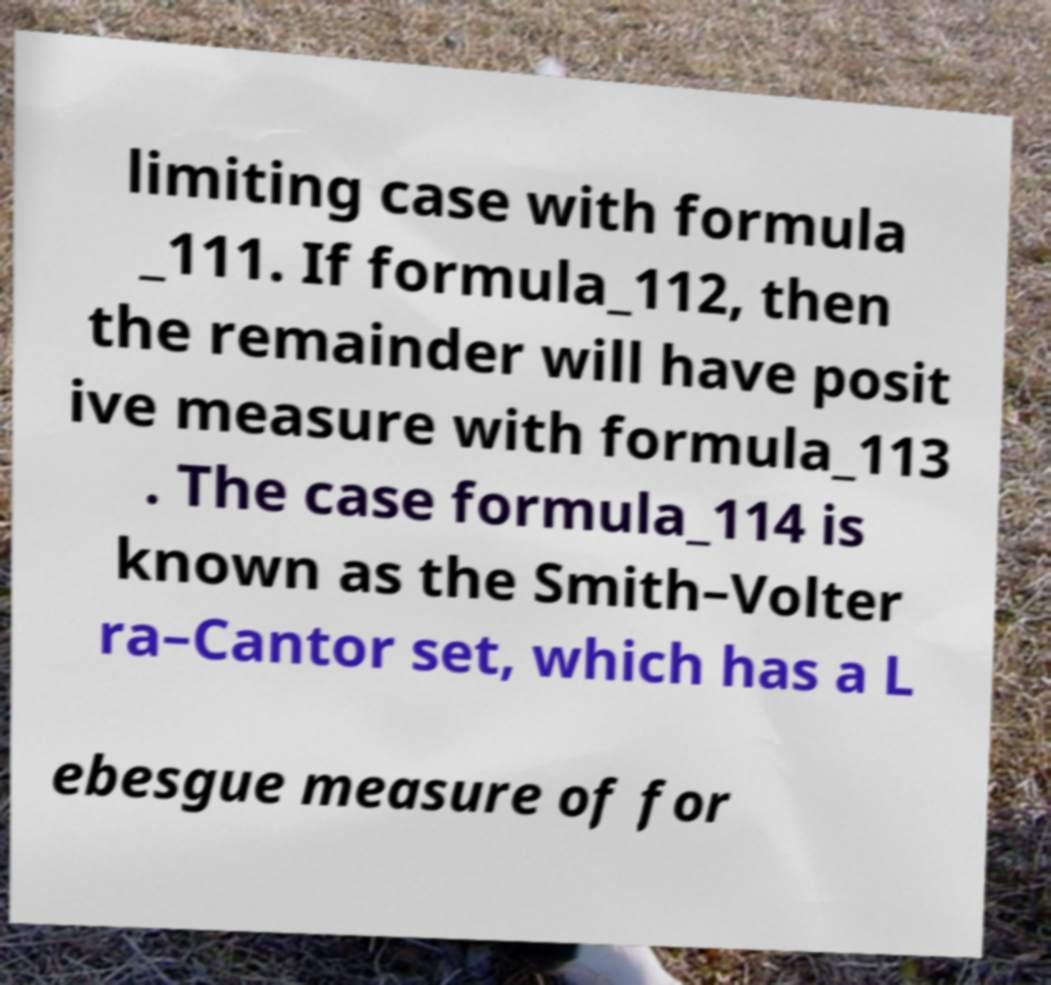For documentation purposes, I need the text within this image transcribed. Could you provide that? limiting case with formula _111. If formula_112, then the remainder will have posit ive measure with formula_113 . The case formula_114 is known as the Smith–Volter ra–Cantor set, which has a L ebesgue measure of for 